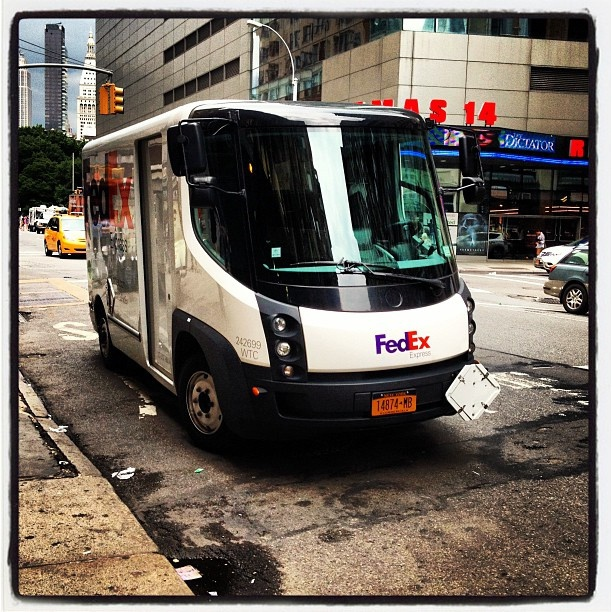Describe the objects in this image and their specific colors. I can see truck in white, black, ivory, gray, and darkgray tones, car in white, black, gray, ivory, and darkgray tones, car in white, ivory, orange, black, and khaki tones, car in white, black, gray, darkgray, and purple tones, and car in white, black, gray, and darkgray tones in this image. 